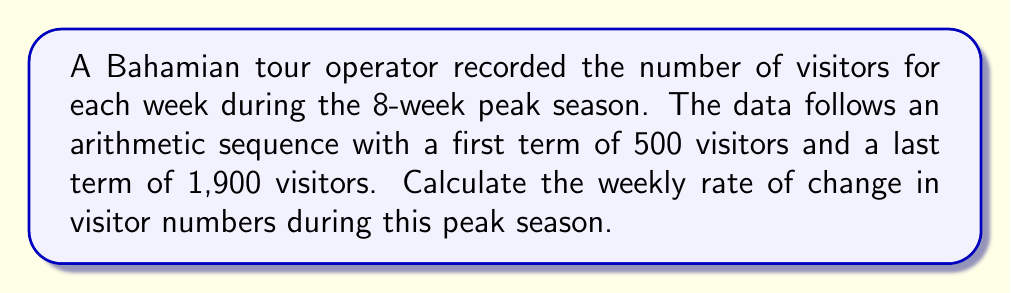What is the answer to this math problem? Let's approach this step-by-step:

1) In an arithmetic sequence, the difference between any two consecutive terms is constant. Let's call this common difference $d$.

2) We know:
   - First term, $a_1 = 500$
   - Last term, $a_8 = 1900$ (since there are 8 weeks)
   - Number of terms, $n = 8$

3) For an arithmetic sequence, the last term is given by:
   $$a_n = a_1 + (n-1)d$$

4) Substituting our known values:
   $$1900 = 500 + (8-1)d$$

5) Simplify:
   $$1900 = 500 + 7d$$

6) Solve for $d$:
   $$1400 = 7d$$
   $$d = 1400 / 7 = 200$$

7) The common difference $d$ represents the change in visitor numbers from one week to the next, which is the weekly rate of change.

Therefore, the weekly rate of change in visitor numbers during the peak season is 200 visitors per week.
Answer: 200 visitors/week 